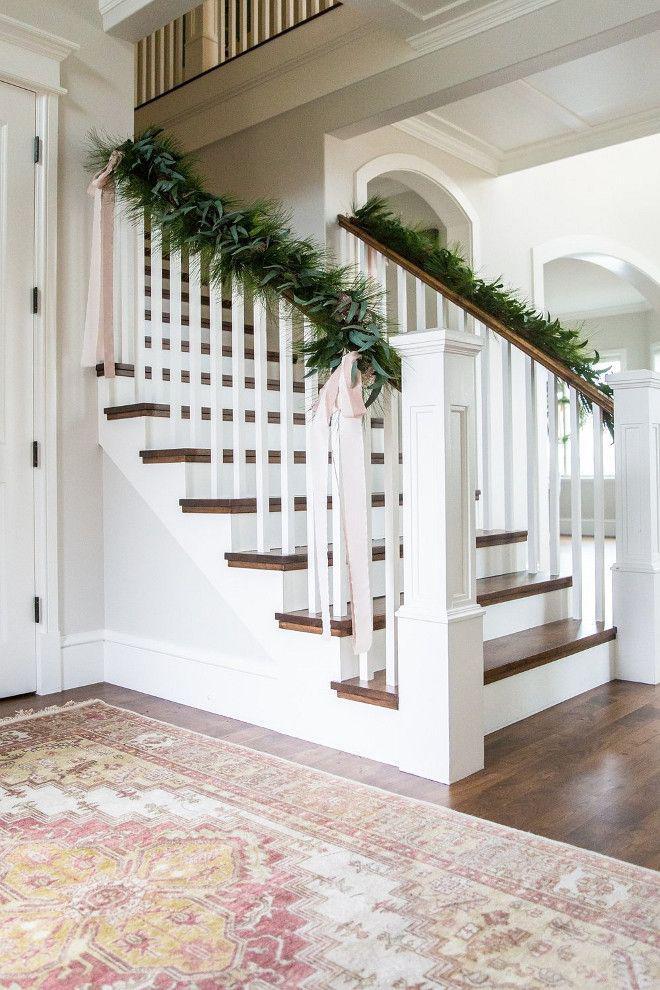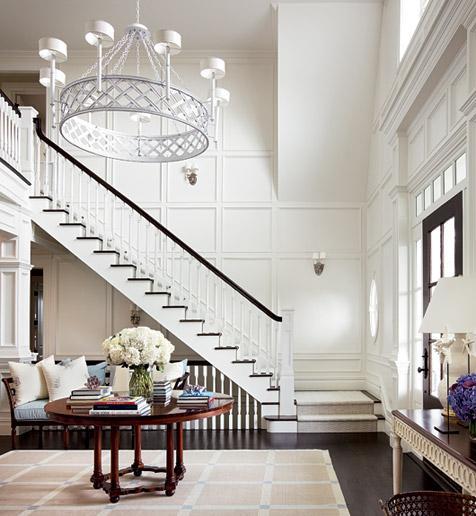The first image is the image on the left, the second image is the image on the right. For the images displayed, is the sentence "One image shows a staircase that curves to the left as it descends and has brown steps with white base boards and a black handrail." factually correct? Answer yes or no. No. The first image is the image on the left, the second image is the image on the right. Considering the images on both sides, is "There is at least one vase with white flowers in it sitting on a table." valid? Answer yes or no. Yes. 